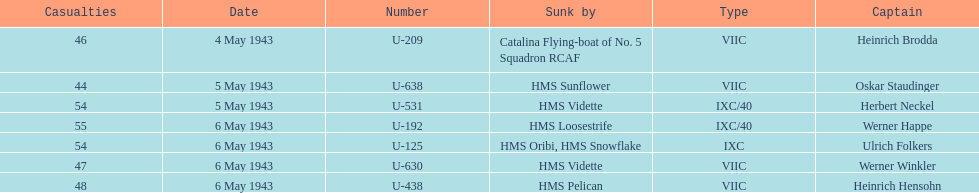How many more casualties occurred on may 6 compared to may 4? 158. 